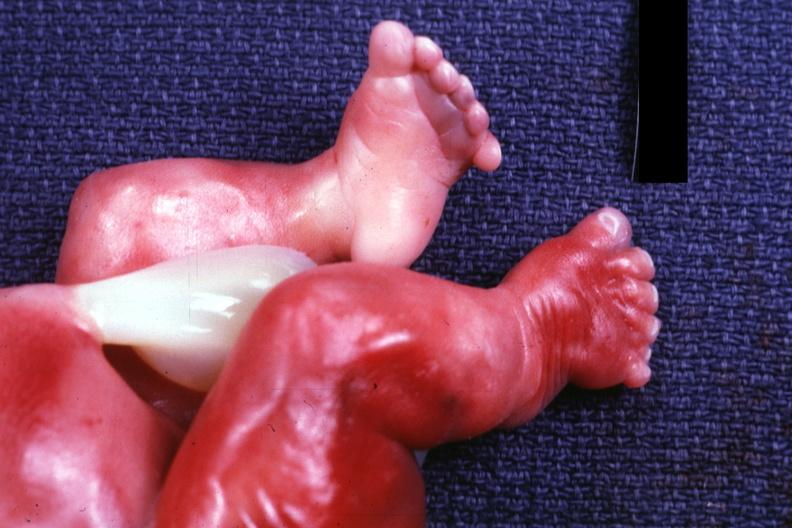what is present?
Answer the question using a single word or phrase. Foot 